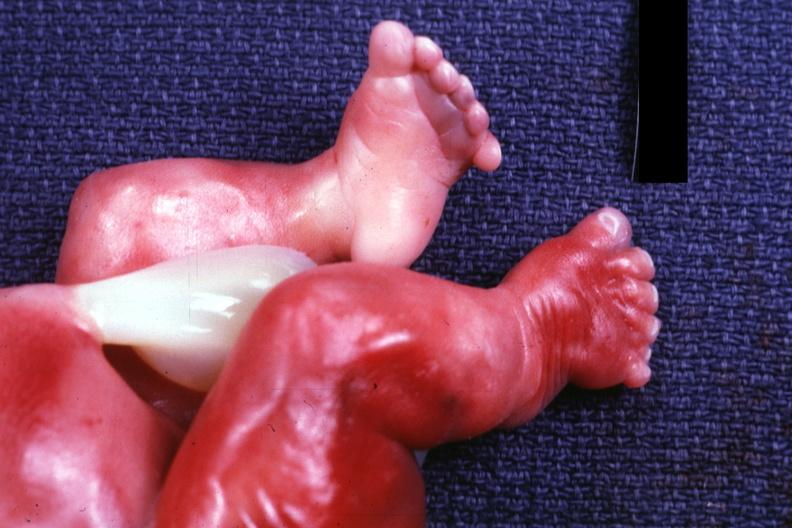what is present?
Answer the question using a single word or phrase. Foot 